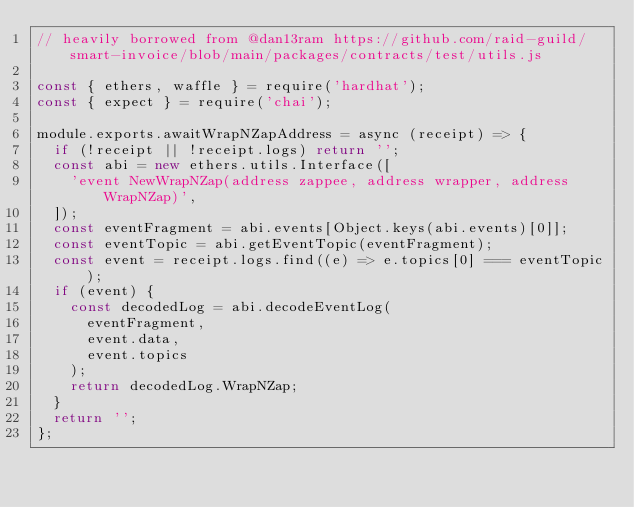Convert code to text. <code><loc_0><loc_0><loc_500><loc_500><_JavaScript_>// heavily borrowed from @dan13ram https://github.com/raid-guild/smart-invoice/blob/main/packages/contracts/test/utils.js

const { ethers, waffle } = require('hardhat');
const { expect } = require('chai');

module.exports.awaitWrapNZapAddress = async (receipt) => {
	if (!receipt || !receipt.logs) return '';
	const abi = new ethers.utils.Interface([
		'event NewWrapNZap(address zappee, address wrapper, address WrapNZap)',
	]);
	const eventFragment = abi.events[Object.keys(abi.events)[0]];
	const eventTopic = abi.getEventTopic(eventFragment);
	const event = receipt.logs.find((e) => e.topics[0] === eventTopic);
	if (event) {
		const decodedLog = abi.decodeEventLog(
			eventFragment,
			event.data,
			event.topics
		);
		return decodedLog.WrapNZap;
	}
	return '';
};
</code> 